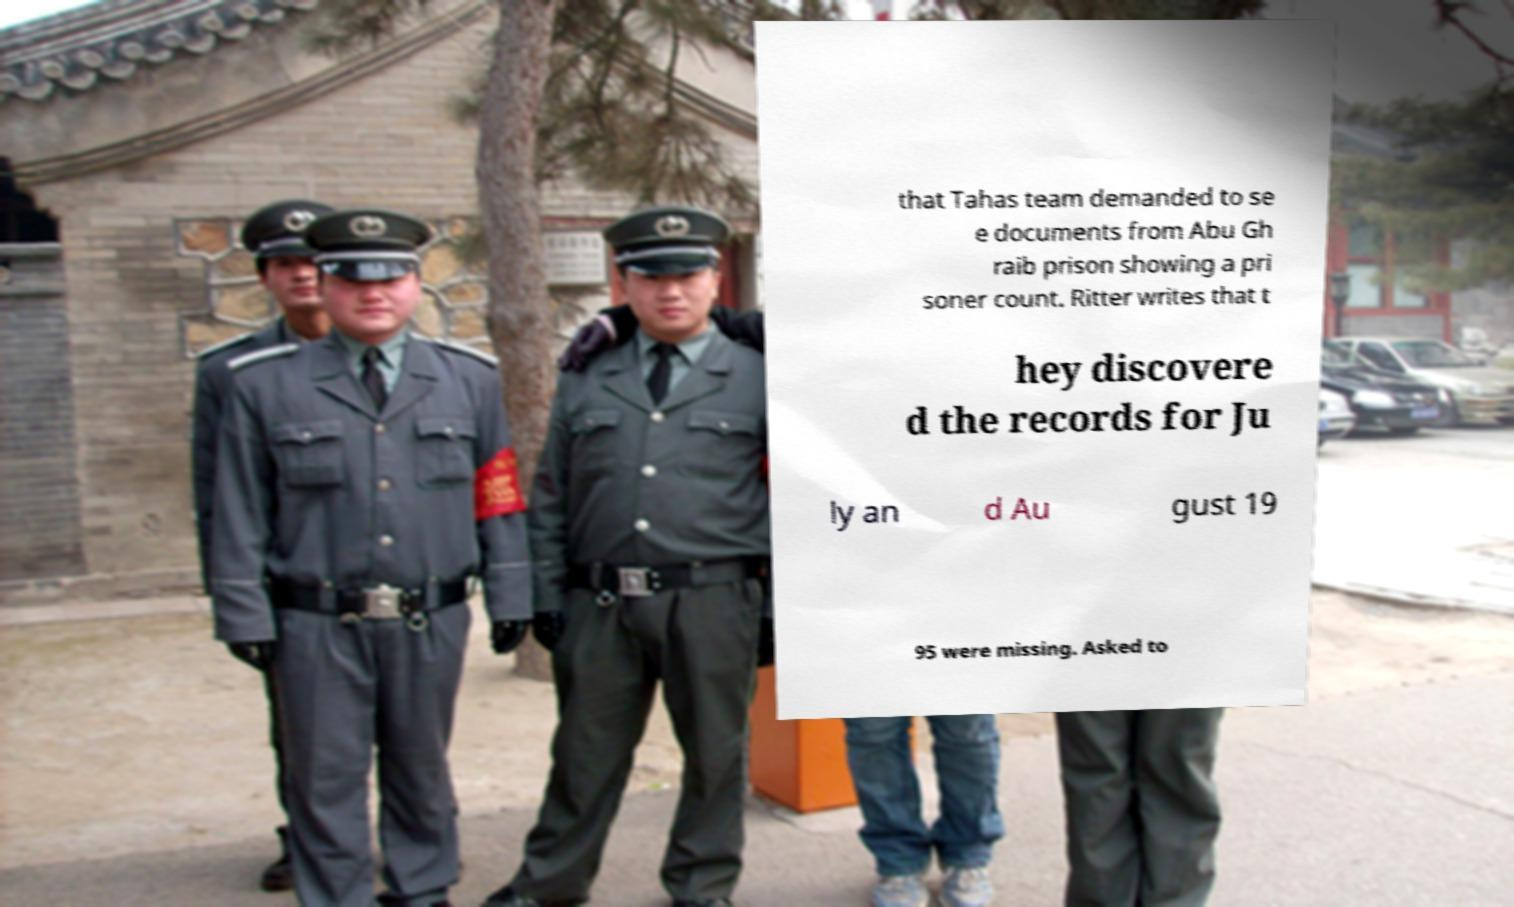Please identify and transcribe the text found in this image. that Tahas team demanded to se e documents from Abu Gh raib prison showing a pri soner count. Ritter writes that t hey discovere d the records for Ju ly an d Au gust 19 95 were missing. Asked to 